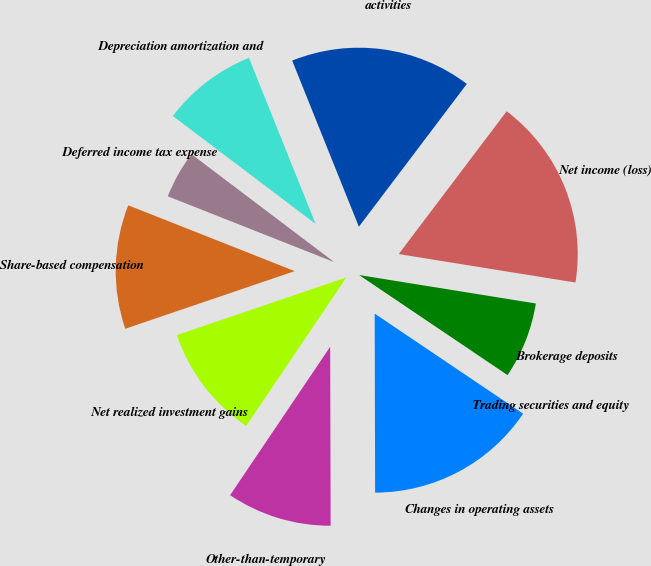<chart> <loc_0><loc_0><loc_500><loc_500><pie_chart><fcel>Net income (loss)<fcel>activities<fcel>Depreciation amortization and<fcel>Deferred income tax expense<fcel>Share-based compensation<fcel>Net realized investment gains<fcel>Other-than-temporary<fcel>Changes in operating assets<fcel>Trading securities and equity<fcel>Brokerage deposits<nl><fcel>17.24%<fcel>16.38%<fcel>8.62%<fcel>4.31%<fcel>11.21%<fcel>10.34%<fcel>9.48%<fcel>15.52%<fcel>0.0%<fcel>6.9%<nl></chart> 